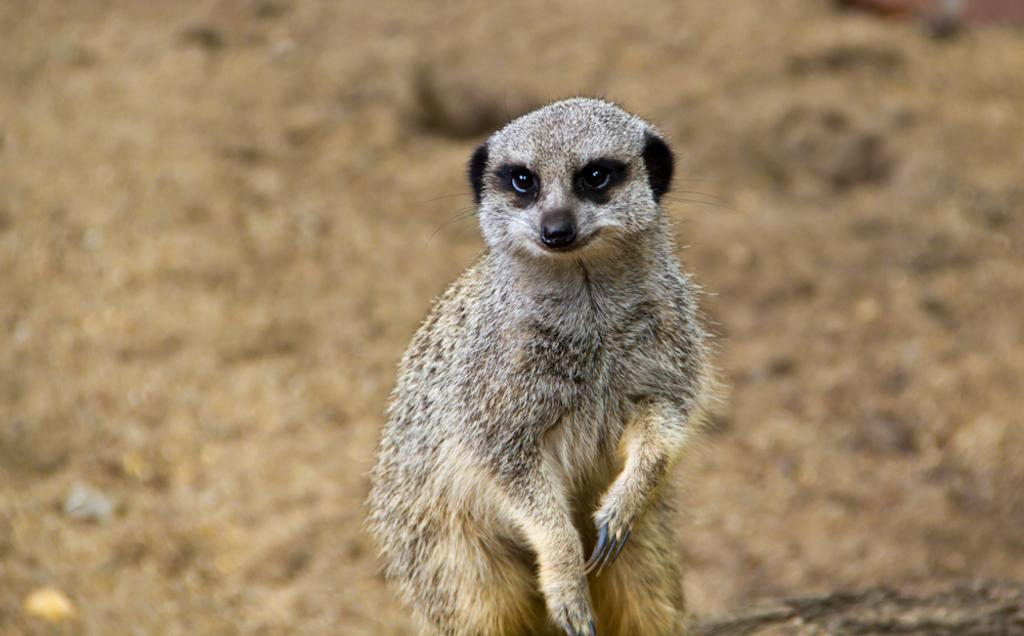What animal is the main subject of the picture? There is a meerkat in the picture. Can you describe the background of the picture? The background of the picture is blurry. What type of toys can be seen on the table in the picture? There is no table or toys present in the picture; it features a meerkat with a blurry background. What is the mass of the meerkat in the picture? The mass of the meerkat cannot be determined from the picture alone, as it does not provide any information about its size or weight. 